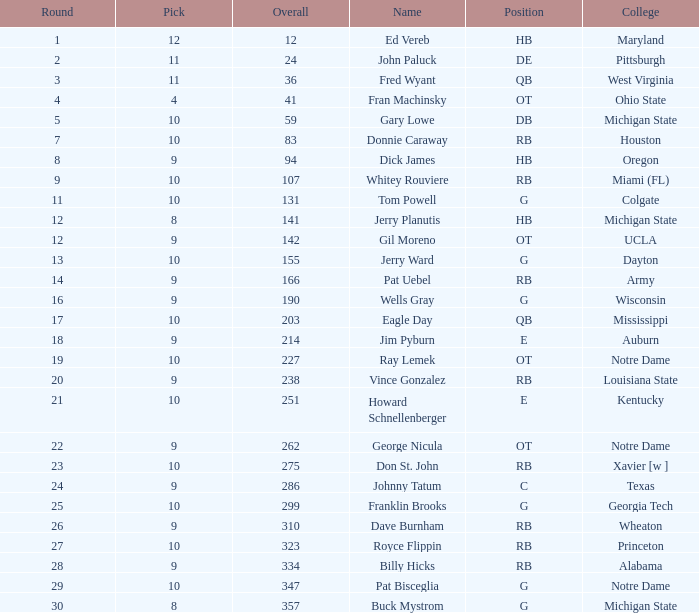What is the sum of rounds that has a pick of 9 and is named jim pyburn? 18.0. Give me the full table as a dictionary. {'header': ['Round', 'Pick', 'Overall', 'Name', 'Position', 'College'], 'rows': [['1', '12', '12', 'Ed Vereb', 'HB', 'Maryland'], ['2', '11', '24', 'John Paluck', 'DE', 'Pittsburgh'], ['3', '11', '36', 'Fred Wyant', 'QB', 'West Virginia'], ['4', '4', '41', 'Fran Machinsky', 'OT', 'Ohio State'], ['5', '10', '59', 'Gary Lowe', 'DB', 'Michigan State'], ['7', '10', '83', 'Donnie Caraway', 'RB', 'Houston'], ['8', '9', '94', 'Dick James', 'HB', 'Oregon'], ['9', '10', '107', 'Whitey Rouviere', 'RB', 'Miami (FL)'], ['11', '10', '131', 'Tom Powell', 'G', 'Colgate'], ['12', '8', '141', 'Jerry Planutis', 'HB', 'Michigan State'], ['12', '9', '142', 'Gil Moreno', 'OT', 'UCLA'], ['13', '10', '155', 'Jerry Ward', 'G', 'Dayton'], ['14', '9', '166', 'Pat Uebel', 'RB', 'Army'], ['16', '9', '190', 'Wells Gray', 'G', 'Wisconsin'], ['17', '10', '203', 'Eagle Day', 'QB', 'Mississippi'], ['18', '9', '214', 'Jim Pyburn', 'E', 'Auburn'], ['19', '10', '227', 'Ray Lemek', 'OT', 'Notre Dame'], ['20', '9', '238', 'Vince Gonzalez', 'RB', 'Louisiana State'], ['21', '10', '251', 'Howard Schnellenberger', 'E', 'Kentucky'], ['22', '9', '262', 'George Nicula', 'OT', 'Notre Dame'], ['23', '10', '275', 'Don St. John', 'RB', 'Xavier [w ]'], ['24', '9', '286', 'Johnny Tatum', 'C', 'Texas'], ['25', '10', '299', 'Franklin Brooks', 'G', 'Georgia Tech'], ['26', '9', '310', 'Dave Burnham', 'RB', 'Wheaton'], ['27', '10', '323', 'Royce Flippin', 'RB', 'Princeton'], ['28', '9', '334', 'Billy Hicks', 'RB', 'Alabama'], ['29', '10', '347', 'Pat Bisceglia', 'G', 'Notre Dame'], ['30', '8', '357', 'Buck Mystrom', 'G', 'Michigan State']]} 